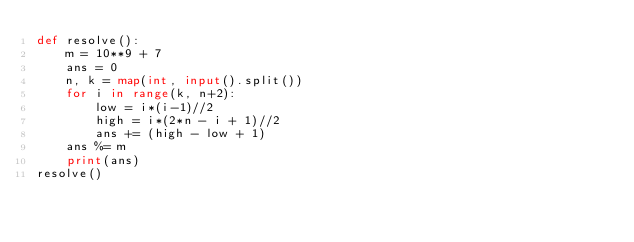Convert code to text. <code><loc_0><loc_0><loc_500><loc_500><_Python_>def resolve():
    m = 10**9 + 7
    ans = 0
    n, k = map(int, input().split())
    for i in range(k, n+2):
        low = i*(i-1)//2
        high = i*(2*n - i + 1)//2
        ans += (high - low + 1)
    ans %= m
    print(ans)
resolve()</code> 